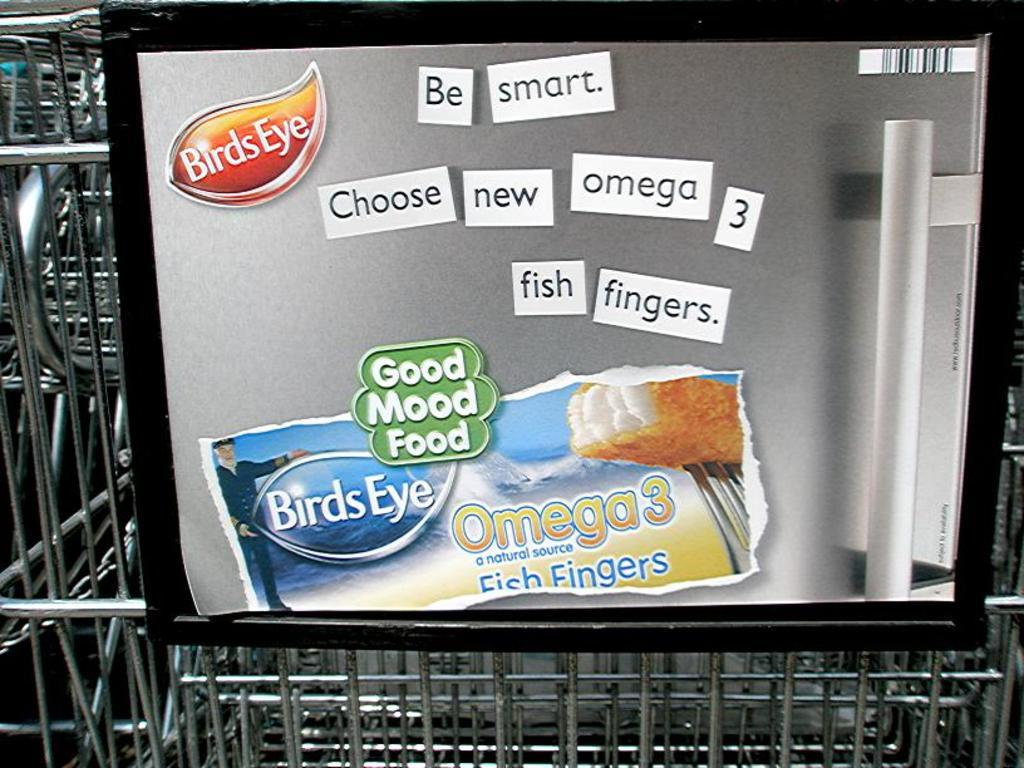<image>
Offer a succinct explanation of the picture presented. An advertisement for BIrds Eye Omega 3 Fish Fingers. 